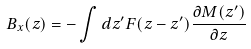Convert formula to latex. <formula><loc_0><loc_0><loc_500><loc_500>B _ { x } ( z ) = - \int d z ^ { \prime } F ( z - z ^ { \prime } ) \frac { \partial M ( z ^ { \prime } ) } { \partial z }</formula> 